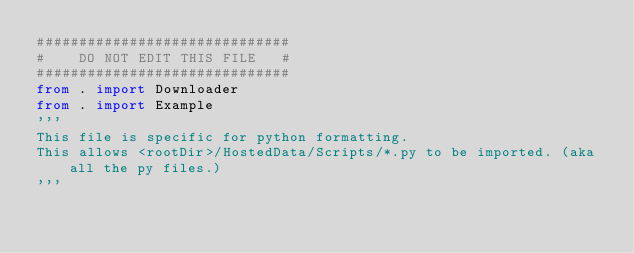Convert code to text. <code><loc_0><loc_0><loc_500><loc_500><_Python_>##############################
#    DO NOT EDIT THIS FILE   #
##############################
from . import Downloader
from . import Example
'''
This file is specific for python formatting.
This allows <rootDir>/HostedData/Scripts/*.py to be imported. (aka all the py files.)
'''
</code> 